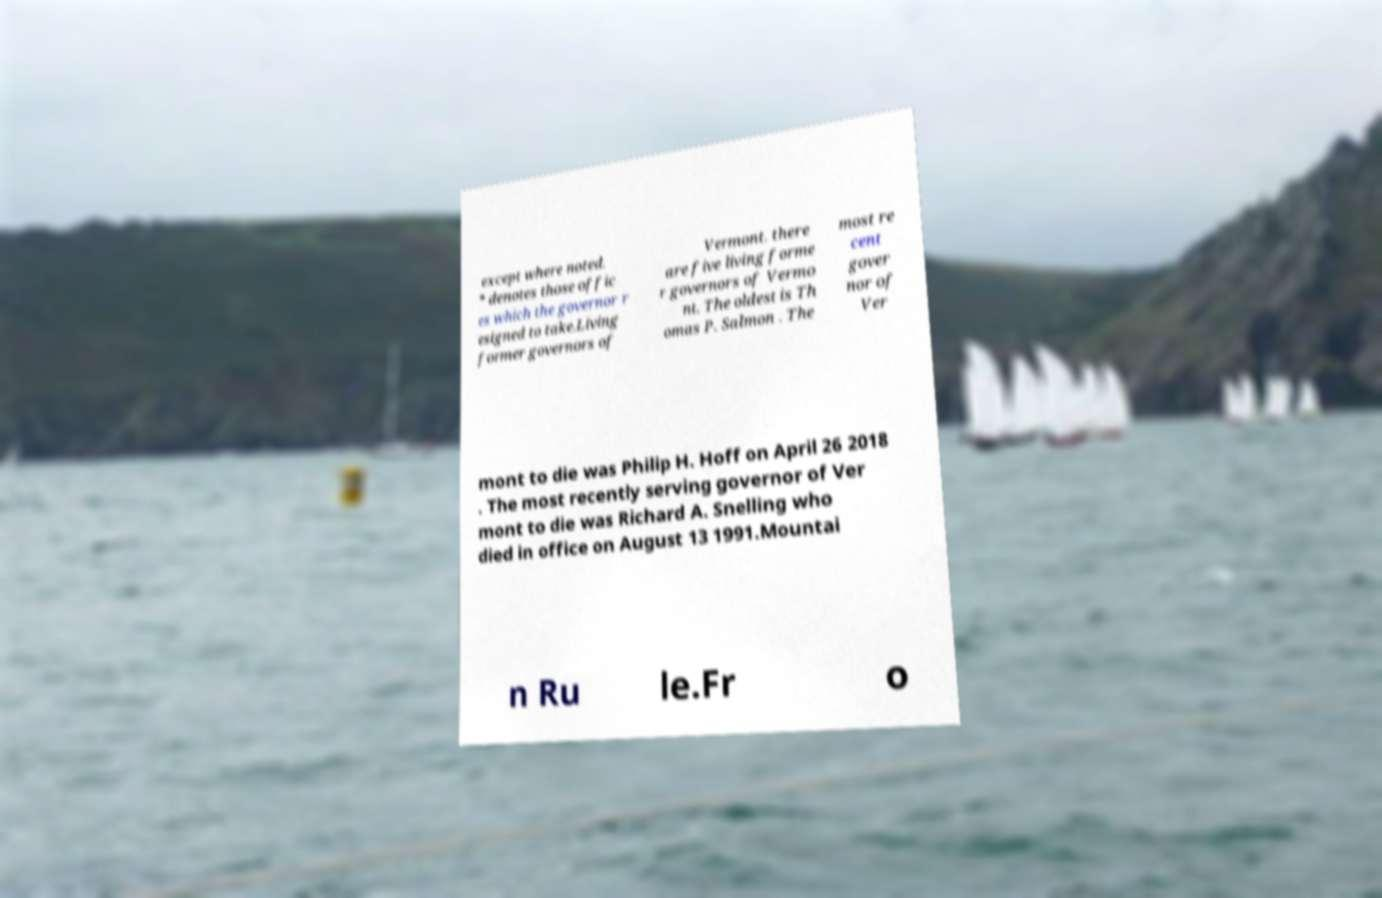Can you accurately transcribe the text from the provided image for me? except where noted. * denotes those offic es which the governor r esigned to take.Living former governors of Vermont. there are five living forme r governors of Vermo nt. The oldest is Th omas P. Salmon . The most re cent gover nor of Ver mont to die was Philip H. Hoff on April 26 2018 . The most recently serving governor of Ver mont to die was Richard A. Snelling who died in office on August 13 1991.Mountai n Ru le.Fr o 